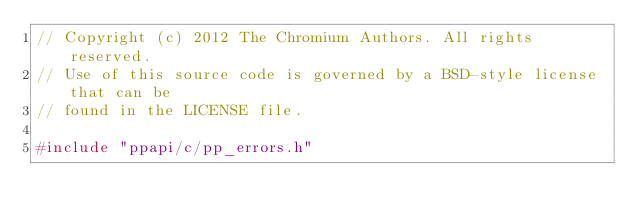Convert code to text. <code><loc_0><loc_0><loc_500><loc_500><_C++_>// Copyright (c) 2012 The Chromium Authors. All rights reserved.
// Use of this source code is governed by a BSD-style license that can be
// found in the LICENSE file.

#include "ppapi/c/pp_errors.h"</code> 